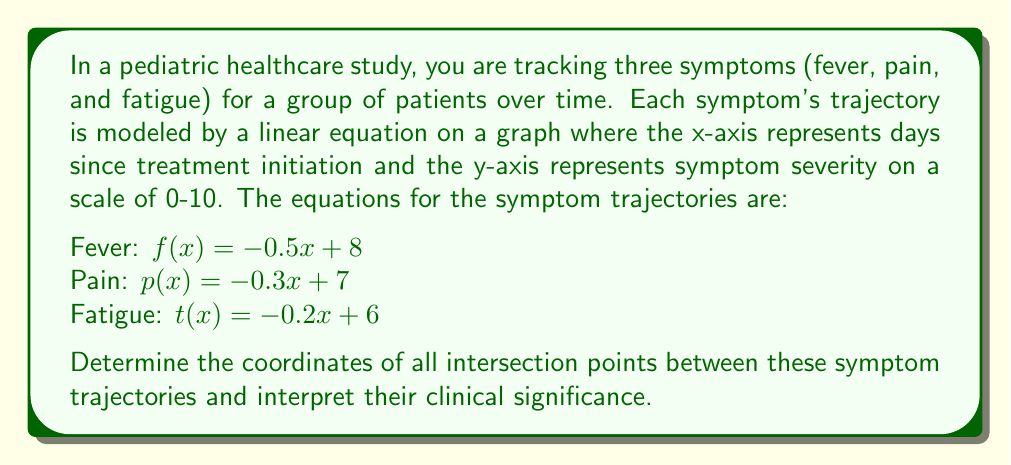Show me your answer to this math problem. To find the intersection points, we need to solve the equations pairwise:

1. Fever and Pain intersection:
   $f(x) = p(x)$
   $-0.5x + 8 = -0.3x + 7$
   $-0.2x = -1$
   $x = 5$
   $y = -0.5(5) + 8 = 5.5$
   Intersection point: $(5, 5.5)$

2. Fever and Fatigue intersection:
   $f(x) = t(x)$
   $-0.5x + 8 = -0.2x + 6$
   $-0.3x = -2$
   $x = \frac{20}{3} \approx 6.67$
   $y = -0.5(\frac{20}{3}) + 8 = \frac{14}{3} \approx 4.67$
   Intersection point: $(\frac{20}{3}, \frac{14}{3})$

3. Pain and Fatigue intersection:
   $p(x) = t(x)$
   $-0.3x + 7 = -0.2x + 6$
   $-0.1x = -1$
   $x = 10$
   $y = -0.3(10) + 7 = 4$
   Intersection point: $(10, 4)$

Clinical interpretation:
- Fever and pain intersect at day 5 with a severity of 5.5, indicating that these symptoms become equally severe at this point.
- Fever and fatigue intersect around day 6.67 with a severity of 4.67, suggesting that fatigue becomes more prominent than fever after this point.
- Pain and fatigue intersect at day 10 with a severity of 4, showing that these symptoms converge later in the treatment process.

These intersection points can help healthcare providers anticipate symptom changes and adjust treatment plans accordingly.
Answer: The intersection points are:
1. Fever and Pain: $(5, 5.5)$
2. Fever and Fatigue: $(\frac{20}{3}, \frac{14}{3})$ or approximately $(6.67, 4.67)$
3. Pain and Fatigue: $(10, 4)$ 